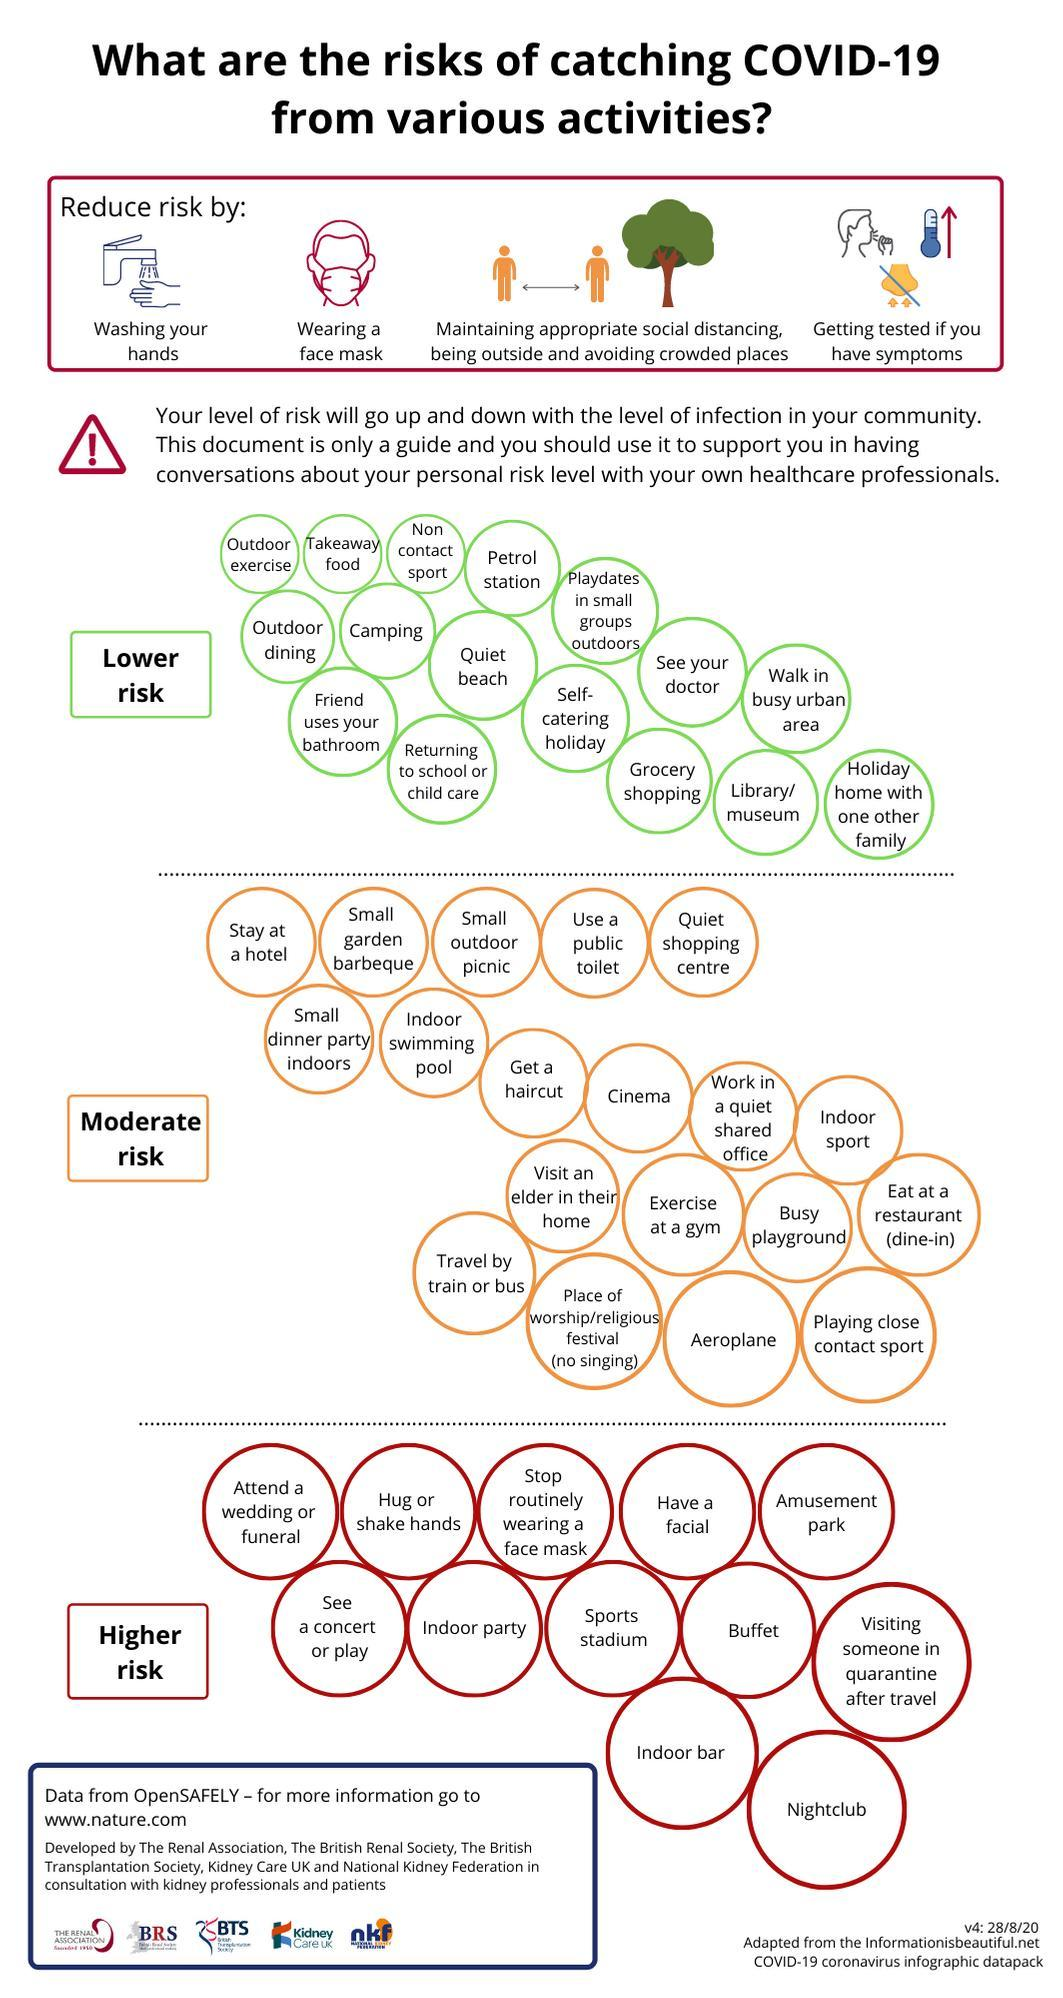How many methods have been mentioned in the info graphic to reduce the risks of Covid 19?
Answer the question with a short phrase. 4 Into how many different categories corona risks are divided? 3 What is the color in which high risk category is listed- orange, green, red, purple? red Walk in busy urban area, Grocery shopping etc falls under which category of Corona Risk? Lower Risk Activities including attending a wedding or funeral, hug or shake hands falls under which risk category? Higher risk How many high risks activities are listed in the info graphic? 12 How many items are listed under lower risk category? 16 How many activities of moderate risk are listed in the info graphic? 19 Activities including Cinema, Aeroplane, Indoor sport falls under which category of corona risks? moderate risk 